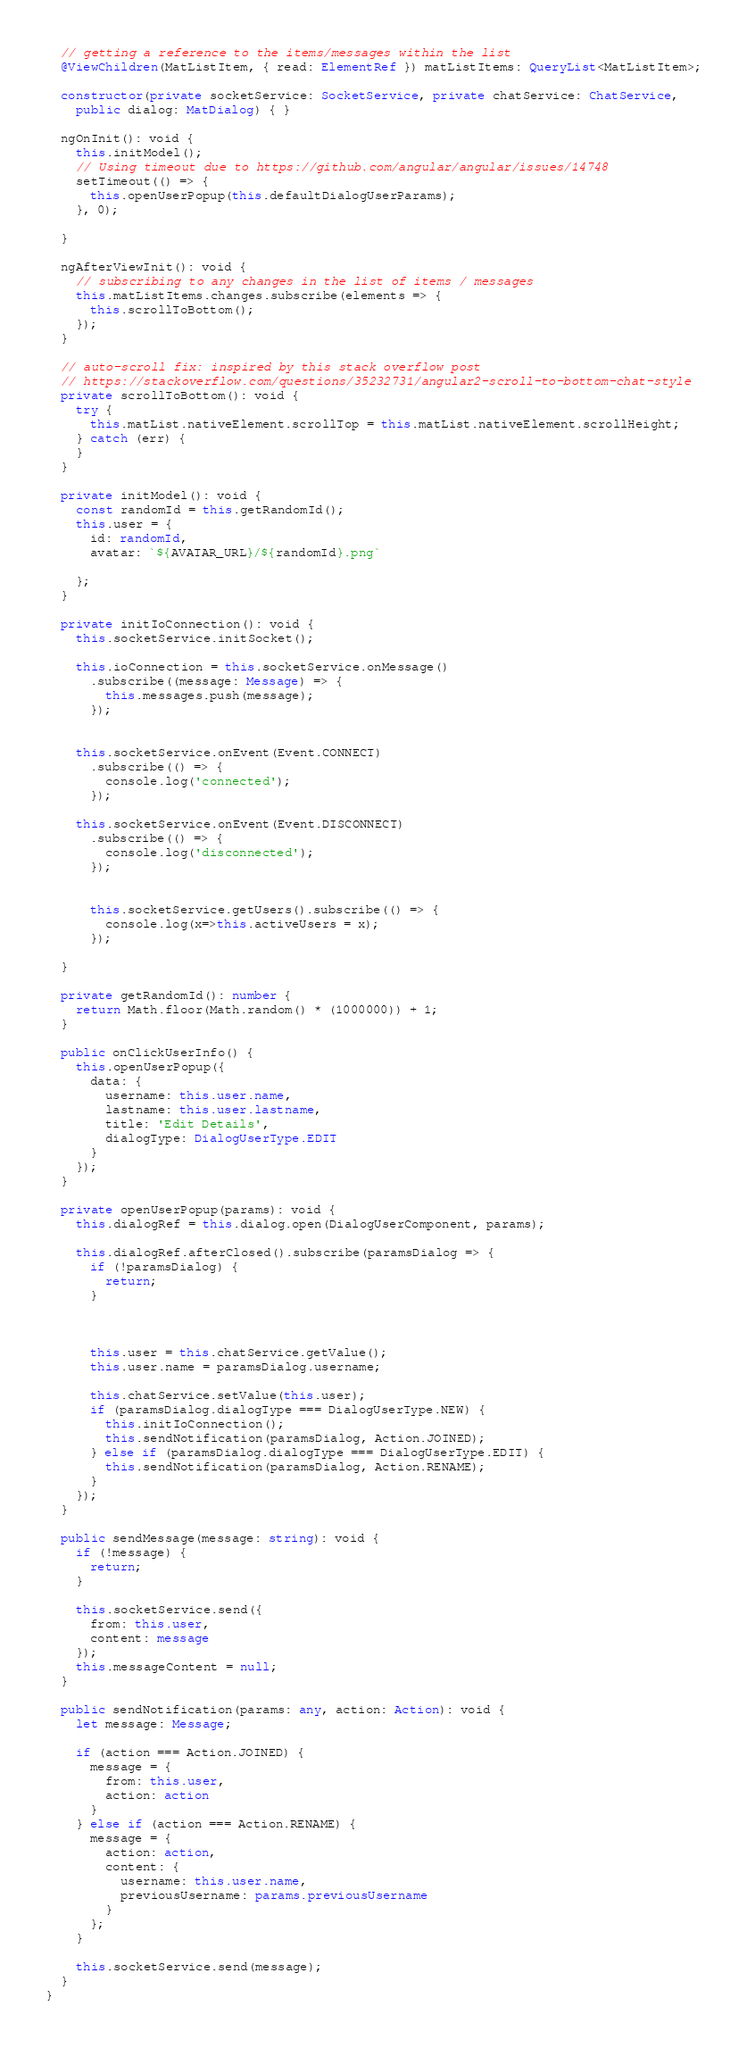Convert code to text. <code><loc_0><loc_0><loc_500><loc_500><_TypeScript_>
  // getting a reference to the items/messages within the list
  @ViewChildren(MatListItem, { read: ElementRef }) matListItems: QueryList<MatListItem>;

  constructor(private socketService: SocketService, private chatService: ChatService,
    public dialog: MatDialog) { }

  ngOnInit(): void {
    this.initModel();
    // Using timeout due to https://github.com/angular/angular/issues/14748
    setTimeout(() => {
      this.openUserPopup(this.defaultDialogUserParams);
    }, 0);

  }

  ngAfterViewInit(): void {
    // subscribing to any changes in the list of items / messages
    this.matListItems.changes.subscribe(elements => {
      this.scrollToBottom();
    });
  }

  // auto-scroll fix: inspired by this stack overflow post
  // https://stackoverflow.com/questions/35232731/angular2-scroll-to-bottom-chat-style
  private scrollToBottom(): void {
    try {
      this.matList.nativeElement.scrollTop = this.matList.nativeElement.scrollHeight;
    } catch (err) {
    }
  }

  private initModel(): void {
    const randomId = this.getRandomId();
    this.user = {
      id: randomId,
      avatar: `${AVATAR_URL}/${randomId}.png`
      
    };
  }

  private initIoConnection(): void {
    this.socketService.initSocket();

    this.ioConnection = this.socketService.onMessage()
      .subscribe((message: Message) => {
        this.messages.push(message);
      });


    this.socketService.onEvent(Event.CONNECT)
      .subscribe(() => {
        console.log('connected');
      });

    this.socketService.onEvent(Event.DISCONNECT)
      .subscribe(() => {
        console.log('disconnected');
      });


      this.socketService.getUsers().subscribe(() => {
        console.log(x=>this.activeUsers = x);
      });

  }

  private getRandomId(): number {
    return Math.floor(Math.random() * (1000000)) + 1;
  }

  public onClickUserInfo() {
    this.openUserPopup({
      data: {
        username: this.user.name,
        lastname: this.user.lastname,
        title: 'Edit Details',
        dialogType: DialogUserType.EDIT
      }
    });
  }

  private openUserPopup(params): void {
    this.dialogRef = this.dialog.open(DialogUserComponent, params);
   
    this.dialogRef.afterClosed().subscribe(paramsDialog => {
      if (!paramsDialog) {
        return;
      }
      
      
    
      this.user = this.chatService.getValue();
      this.user.name = paramsDialog.username;
      
      this.chatService.setValue(this.user);
      if (paramsDialog.dialogType === DialogUserType.NEW) {
        this.initIoConnection();
        this.sendNotification(paramsDialog, Action.JOINED);
      } else if (paramsDialog.dialogType === DialogUserType.EDIT) {
        this.sendNotification(paramsDialog, Action.RENAME);
      }
    });
  }

  public sendMessage(message: string): void {
    if (!message) {
      return;
    }

    this.socketService.send({
      from: this.user,
      content: message
    });
    this.messageContent = null;
  }

  public sendNotification(params: any, action: Action): void {
    let message: Message;

    if (action === Action.JOINED) {
      message = {
        from: this.user,
        action: action
      }
    } else if (action === Action.RENAME) {
      message = {
        action: action,
        content: {
          username: this.user.name,
          previousUsername: params.previousUsername
        }
      };
    }

    this.socketService.send(message);
  }
}
</code> 